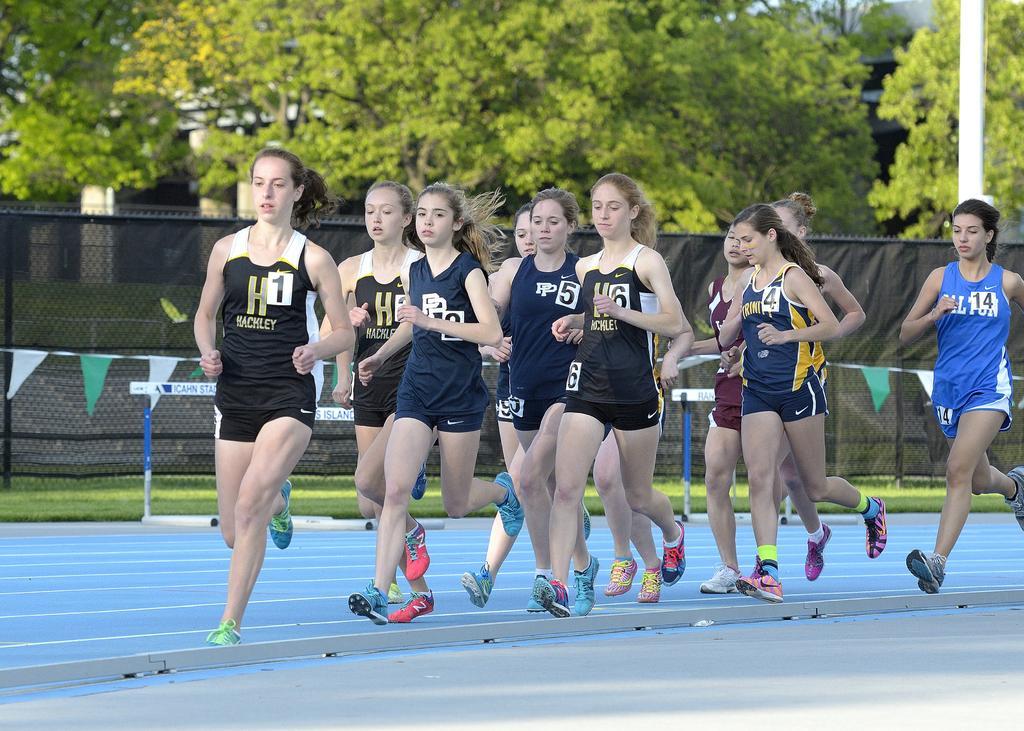Please provide a concise description of this image. In this image we can see women are running, there is a fencing, there are pipes attached to a rope, there are boards with text on it, there is a pole, there are trees, also we can see a house. 